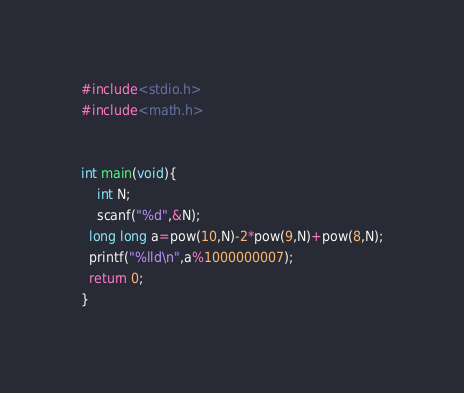Convert code to text. <code><loc_0><loc_0><loc_500><loc_500><_C_>#include<stdio.h>
#include<math.h>


int main(void){
	int N;
  	scanf("%d",&N);
  long long a=pow(10,N)-2*pow(9,N)+pow(8,N);
  printf("%lld\n",a%1000000007);
  return 0;
}</code> 